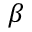<formula> <loc_0><loc_0><loc_500><loc_500>\beta</formula> 